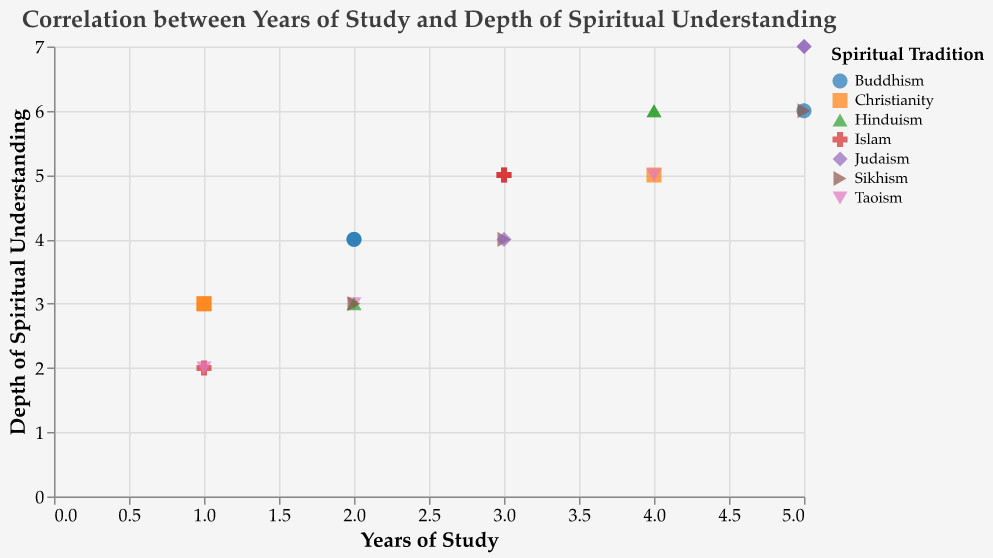What is the title of the plot? The title of the plot is located at the top of the figure and reads "Correlation between Years of Study and Depth of Spiritual Understanding."
Answer: Correlation between Years of Study and Depth of Spiritual Understanding How many data points are plotted in the figure? Each point in the plot represents a data point, and counting all of them, we find there are 21 data points.
Answer: 21 What is the range of "Years of Study" among the theology students? The x-axis represents the "Years of Study" and the minimum is 1 while the maximum is 5.
Answer: 1 to 5 Which spiritual tradition has the highest depth of spiritual understanding for the maximum years of study? For "Years of Study" equal to 5, the point with the highest "Depth of Spiritual Understanding" is 7, and the spiritual tradition corresponding to this point is Judaism.
Answer: Judaism What is the average depth of spiritual understanding for students with 3 years of study? The data points with 3 years of study (3,5), (3,4), (3,5), (3,4) have depths of spiritual understanding values of 5, 4, 5, and 4. The average is (5 + 4 + 5 + 4)/4 = 4.5.
Answer: 4.5 Which spiritual tradition shows the least variation in depth of spiritual understanding across the years of study? By observing the distribution of points across different years of study and their corresponding depth, Buddhism shows the least variation as its depth of spiritual understanding increases uniformly.
Answer: Buddhism How many traditions have more than one data point corresponding to a depth of spiritual understanding of 4? Examining the points at "Depth of Spiritual Understanding" equal to 4, we see there are multiple points for Buddhism, Sikhism, and Judaism.
Answer: 3 For what years of study does Christianity have a depth of spiritual understanding of 3? Observing the points labeled with Christianity, the depth of spiritual understanding is 3 for "Years of Study" equal to 1.
Answer: 1 What is the color associated with the spiritual tradition "Hinduism"? By referring to the legend, Hinduism is represented by a specific color in the plot, which is generally a shade of green (using category10 color scheme).
Answer: Green Identify a pattern in the spiritual understanding growth across all traditions. What does it suggest? Most traditions show an incremental pattern in "Depth of Spiritual Understanding" with increasing "Years of Study", suggesting a positive correlation between study duration and spiritual understanding depth.
Answer: Positive correlation 